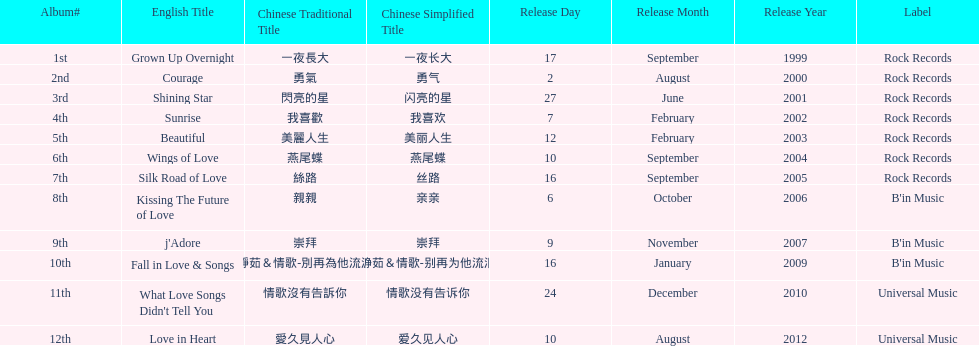Which song is listed first in the table? Grown Up Overnight. 